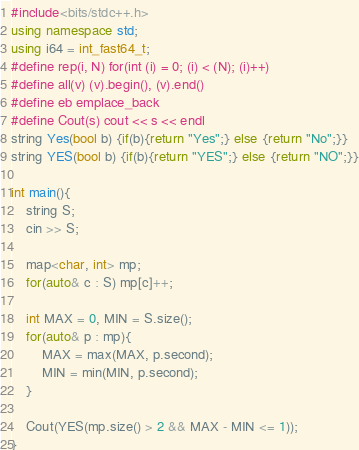Convert code to text. <code><loc_0><loc_0><loc_500><loc_500><_C++_>#include<bits/stdc++.h>
using namespace std;
using i64 = int_fast64_t;
#define rep(i, N) for(int (i) = 0; (i) < (N); (i)++)
#define all(v) (v).begin(), (v).end()
#define eb emplace_back
#define Cout(s) cout << s << endl
string Yes(bool b) {if(b){return "Yes";} else {return "No";}}
string YES(bool b) {if(b){return "YES";} else {return "NO";}}

int main(){
	string S;
	cin >> S;

	map<char, int> mp;
	for(auto& c : S) mp[c]++;

	int MAX = 0, MIN = S.size();
	for(auto& p : mp){
		MAX = max(MAX, p.second);
		MIN = min(MIN, p.second);
	}

	Cout(YES(mp.size() > 2 && MAX - MIN <= 1));
}
</code> 